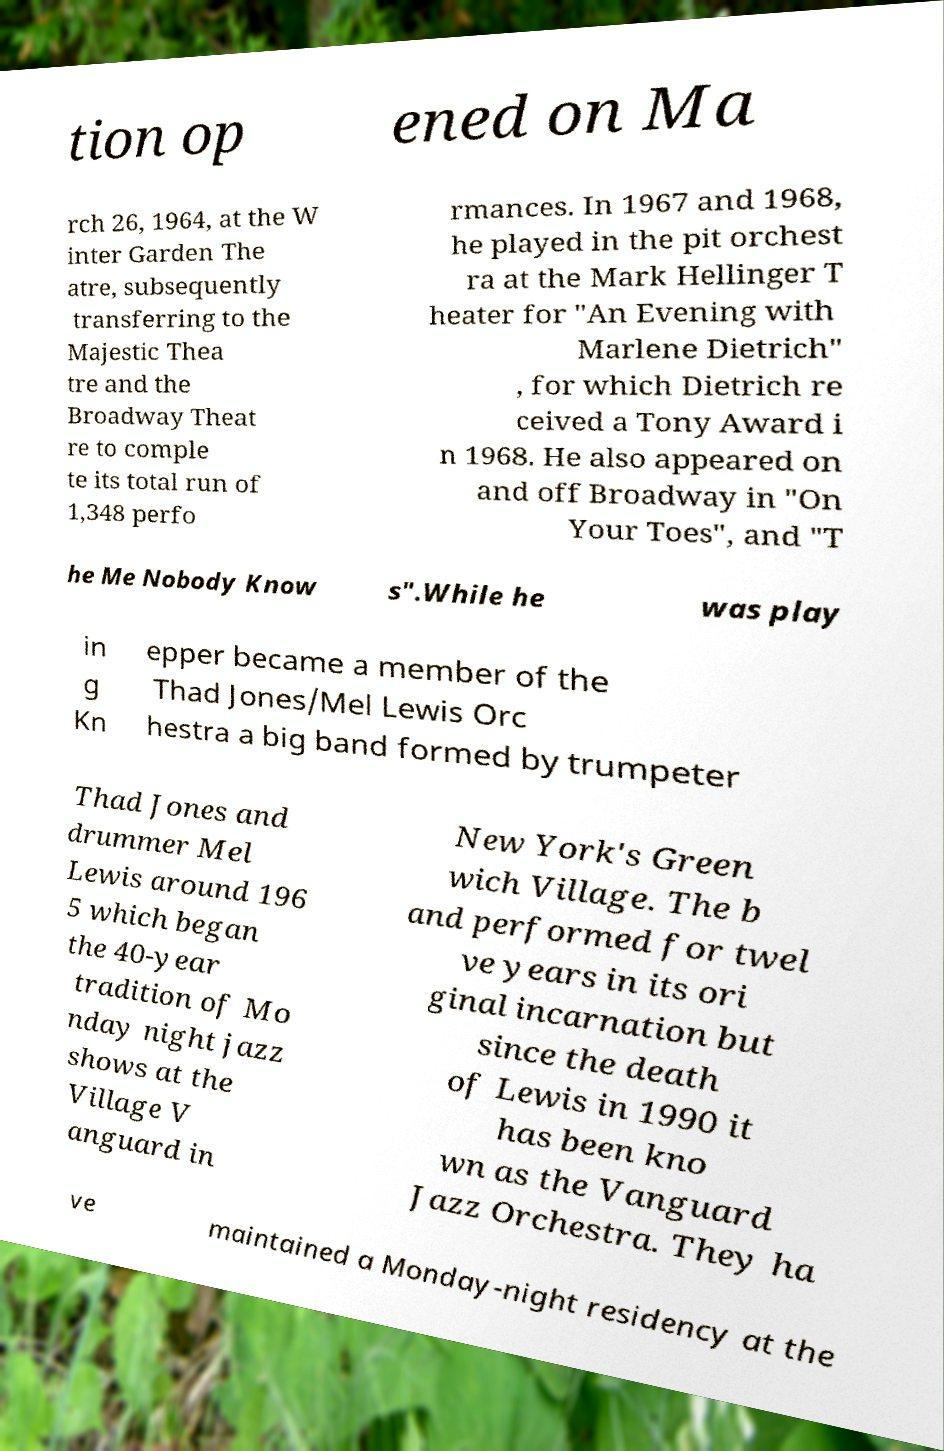What messages or text are displayed in this image? I need them in a readable, typed format. tion op ened on Ma rch 26, 1964, at the W inter Garden The atre, subsequently transferring to the Majestic Thea tre and the Broadway Theat re to comple te its total run of 1,348 perfo rmances. In 1967 and 1968, he played in the pit orchest ra at the Mark Hellinger T heater for "An Evening with Marlene Dietrich" , for which Dietrich re ceived a Tony Award i n 1968. He also appeared on and off Broadway in "On Your Toes", and "T he Me Nobody Know s".While he was play in g Kn epper became a member of the Thad Jones/Mel Lewis Orc hestra a big band formed by trumpeter Thad Jones and drummer Mel Lewis around 196 5 which began the 40-year tradition of Mo nday night jazz shows at the Village V anguard in New York's Green wich Village. The b and performed for twel ve years in its ori ginal incarnation but since the death of Lewis in 1990 it has been kno wn as the Vanguard Jazz Orchestra. They ha ve maintained a Monday-night residency at the 